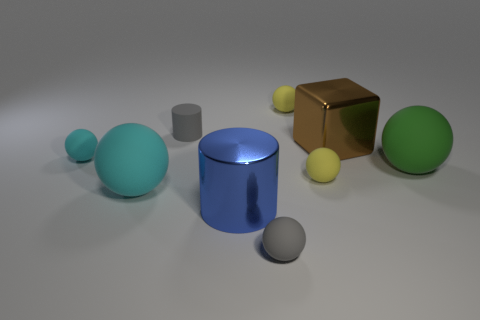How big is the metallic object that is behind the big cylinder?
Provide a succinct answer. Large. What is the material of the object that is the same color as the rubber cylinder?
Offer a very short reply. Rubber. There is a large ball to the left of the gray object that is in front of the big cyan ball; what color is it?
Give a very brief answer. Cyan. How many matte objects are large things or large green balls?
Ensure brevity in your answer.  2. Are the gray cylinder and the large block made of the same material?
Provide a short and direct response. No. There is a small gray object behind the rubber thing that is to the left of the big cyan matte object; what is it made of?
Make the answer very short. Rubber. How many big objects are purple cubes or brown things?
Ensure brevity in your answer.  1. The block is what size?
Make the answer very short. Large. Are there more tiny cyan matte objects that are on the left side of the blue cylinder than small purple things?
Offer a very short reply. Yes. Are there an equal number of balls that are behind the blue thing and balls that are in front of the brown metallic thing?
Provide a succinct answer. Yes. 